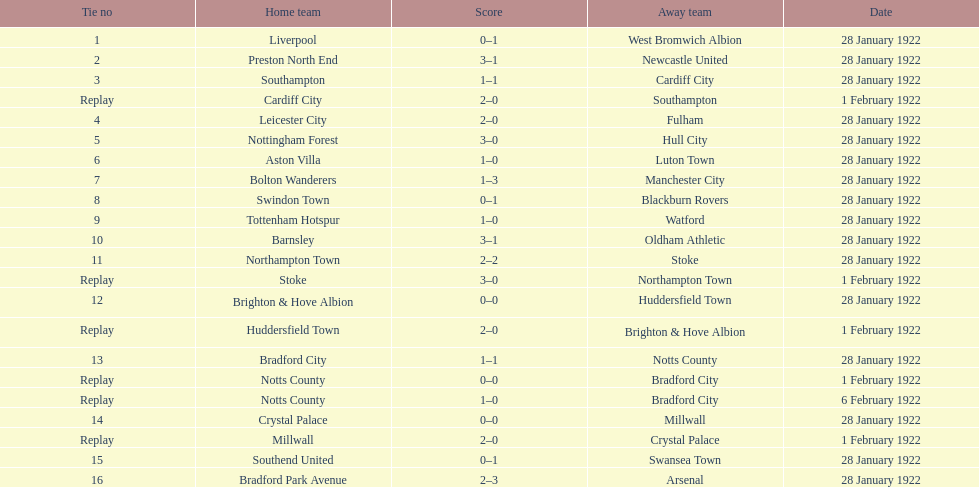How many total points were scored in the second round proper? 45. 